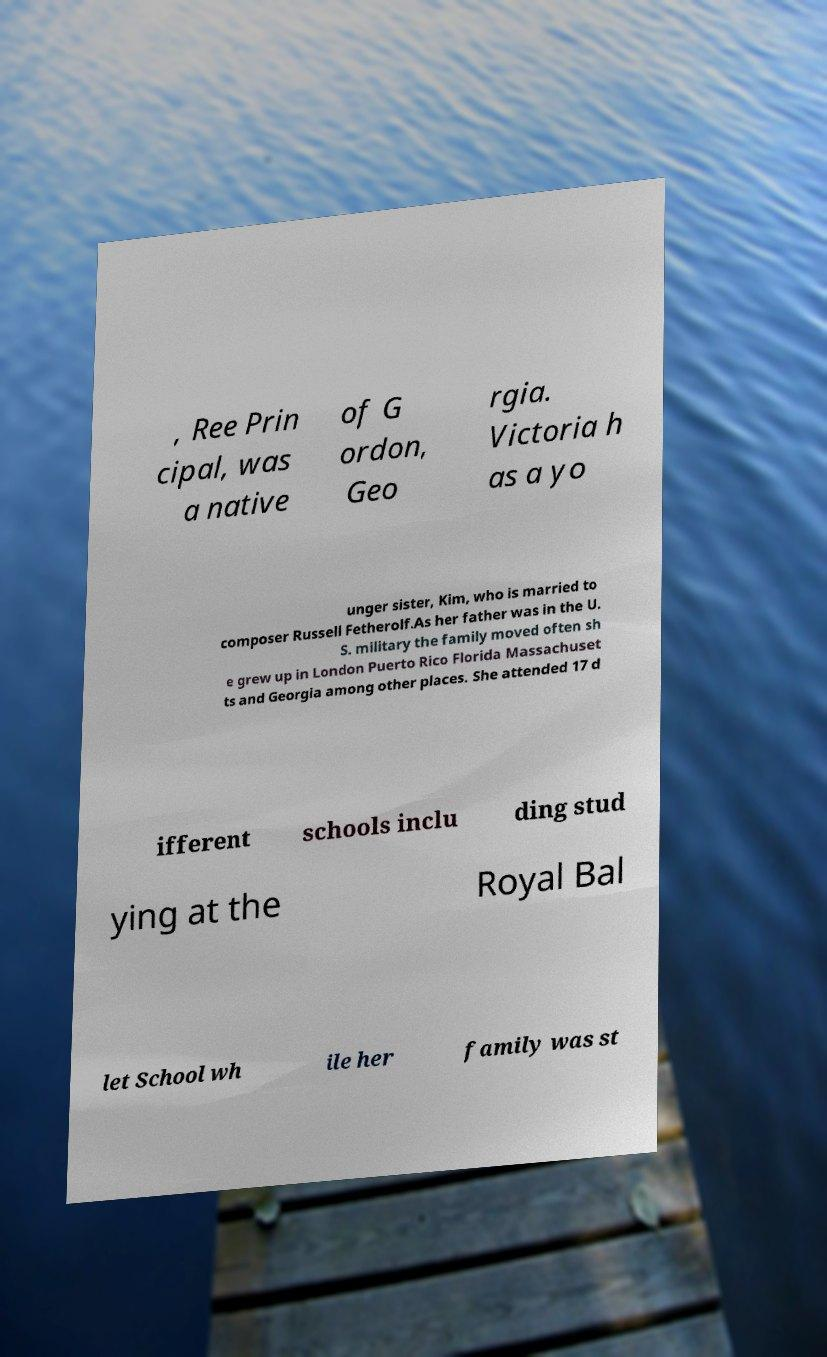Could you assist in decoding the text presented in this image and type it out clearly? , Ree Prin cipal, was a native of G ordon, Geo rgia. Victoria h as a yo unger sister, Kim, who is married to composer Russell Fetherolf.As her father was in the U. S. military the family moved often sh e grew up in London Puerto Rico Florida Massachuset ts and Georgia among other places. She attended 17 d ifferent schools inclu ding stud ying at the Royal Bal let School wh ile her family was st 